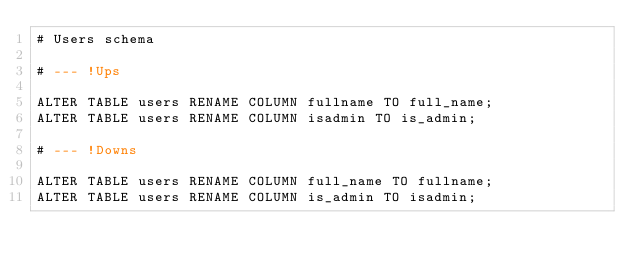Convert code to text. <code><loc_0><loc_0><loc_500><loc_500><_SQL_># Users schema

# --- !Ups

ALTER TABLE users RENAME COLUMN fullname TO full_name;
ALTER TABLE users RENAME COLUMN isadmin TO is_admin;

# --- !Downs

ALTER TABLE users RENAME COLUMN full_name TO fullname;
ALTER TABLE users RENAME COLUMN is_admin TO isadmin;
</code> 